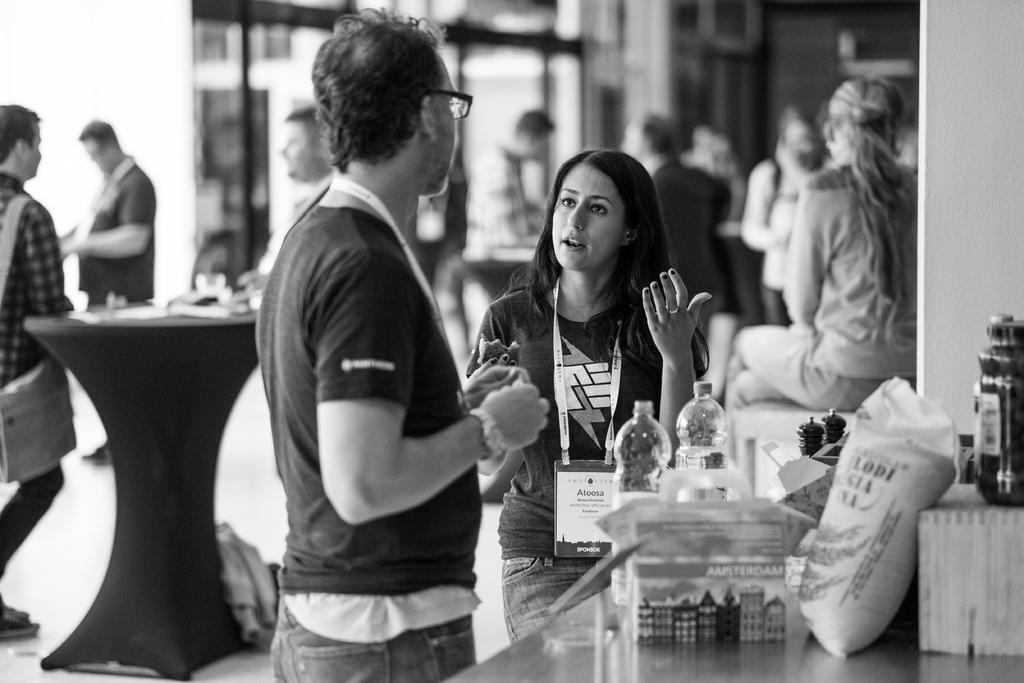Please provide a concise description of this image. In this image we can see a man and woman standing and looking at each other. On the right side of the image we can see a water bottles, bags, and some other things are placed on the table. In the background of the image we can see few more people. 